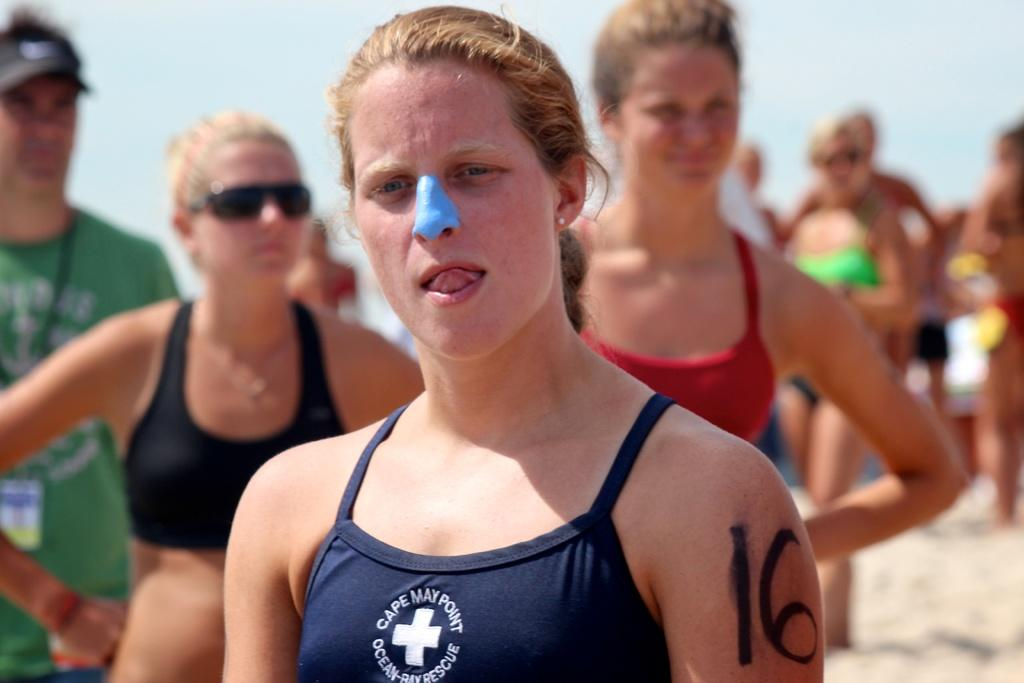Provide a one-sentence caption for the provided image. A woman with a blue substance on her nose wears a Cape May Point bathing suit. 